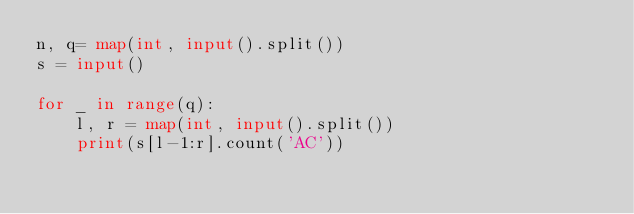<code> <loc_0><loc_0><loc_500><loc_500><_Python_>n, q= map(int, input().split())
s = input()

for _ in range(q):
    l, r = map(int, input().split())
    print(s[l-1:r].count('AC'))</code> 